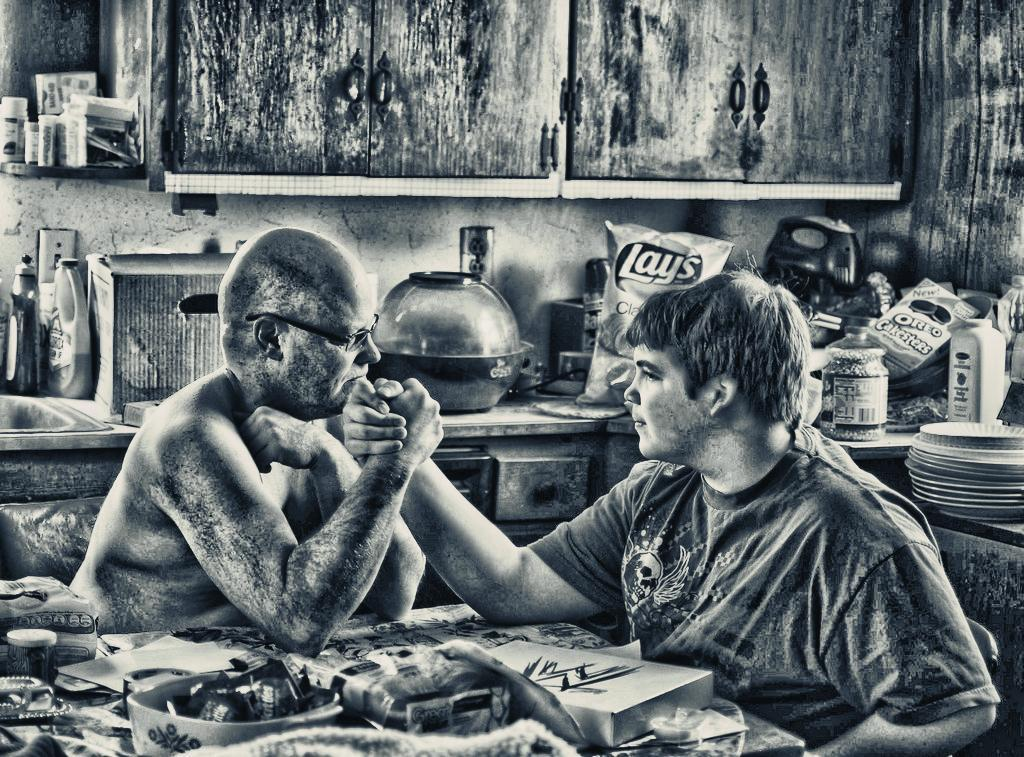How many persons can be seen in the background of the image? There are two persons in the background of the image. What type of items are present in the image? There are eatable items in the image. What type of doll is present in the image? There is no doll present in the image. 